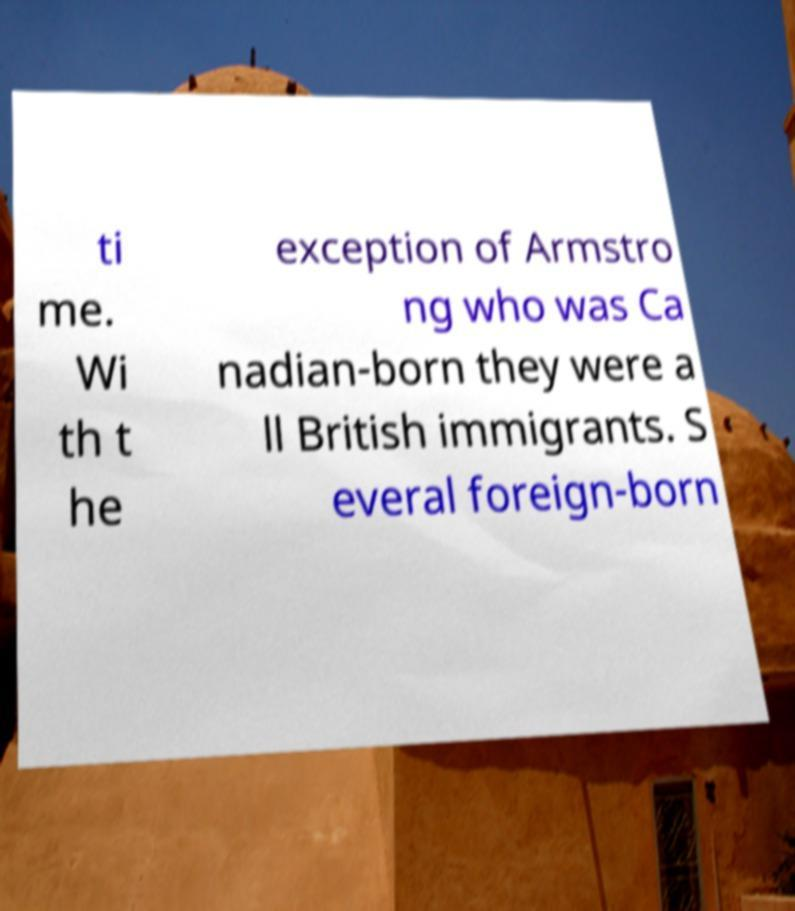Could you assist in decoding the text presented in this image and type it out clearly? ti me. Wi th t he exception of Armstro ng who was Ca nadian-born they were a ll British immigrants. S everal foreign-born 